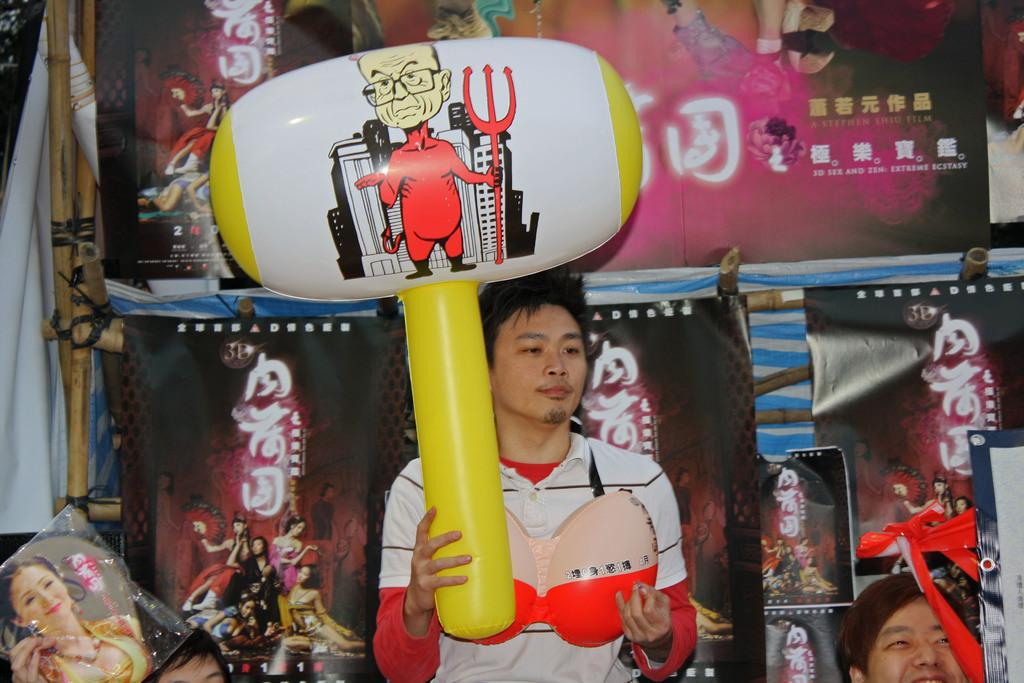What is the main subject of the image? There is a man standing in the center of the image. What is the man holding in his hand? The man is holding a balloon in his hand. What can be seen in the background of the image? There are banners and boards visible in the background of the image. Are there any other people in the image besides the man holding the balloon? Yes, there are people at the bottom of the image. Can you see any goldfish swimming in the image? There are no goldfish present in the image. Is there any indication of a wound on the man holding the balloon? There is no mention or indication of a wound on the man holding the balloon in the image. 